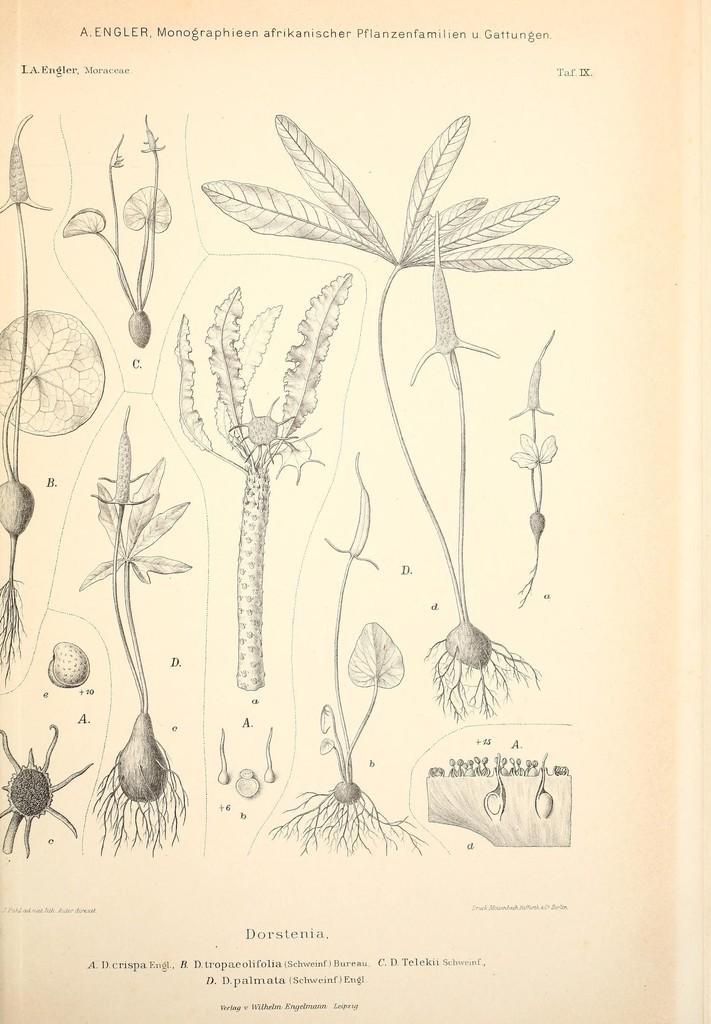What type of images are present in the image? There are pictures of plants with roots in the image. What other elements can be seen in the image besides the plant images? There is edited text at the top and bottom of the image. How many geese are visible in the image? There are no geese present in the image. Is there a gun visible in the image? There is no gun present in the image. 